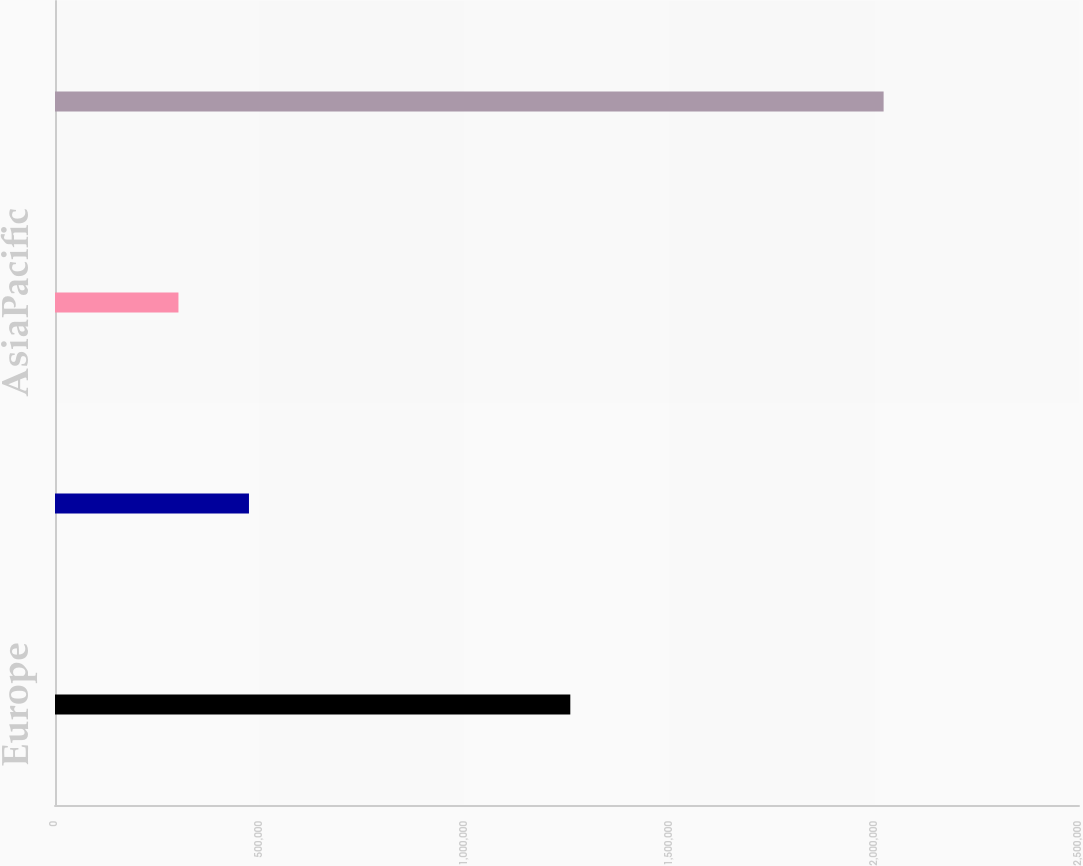<chart> <loc_0><loc_0><loc_500><loc_500><bar_chart><fcel>Europe<fcel>LatinAmerica<fcel>AsiaPacific<fcel>Netrevenues<nl><fcel>1.25808e+06<fcel>473566<fcel>301407<fcel>2.023e+06<nl></chart> 